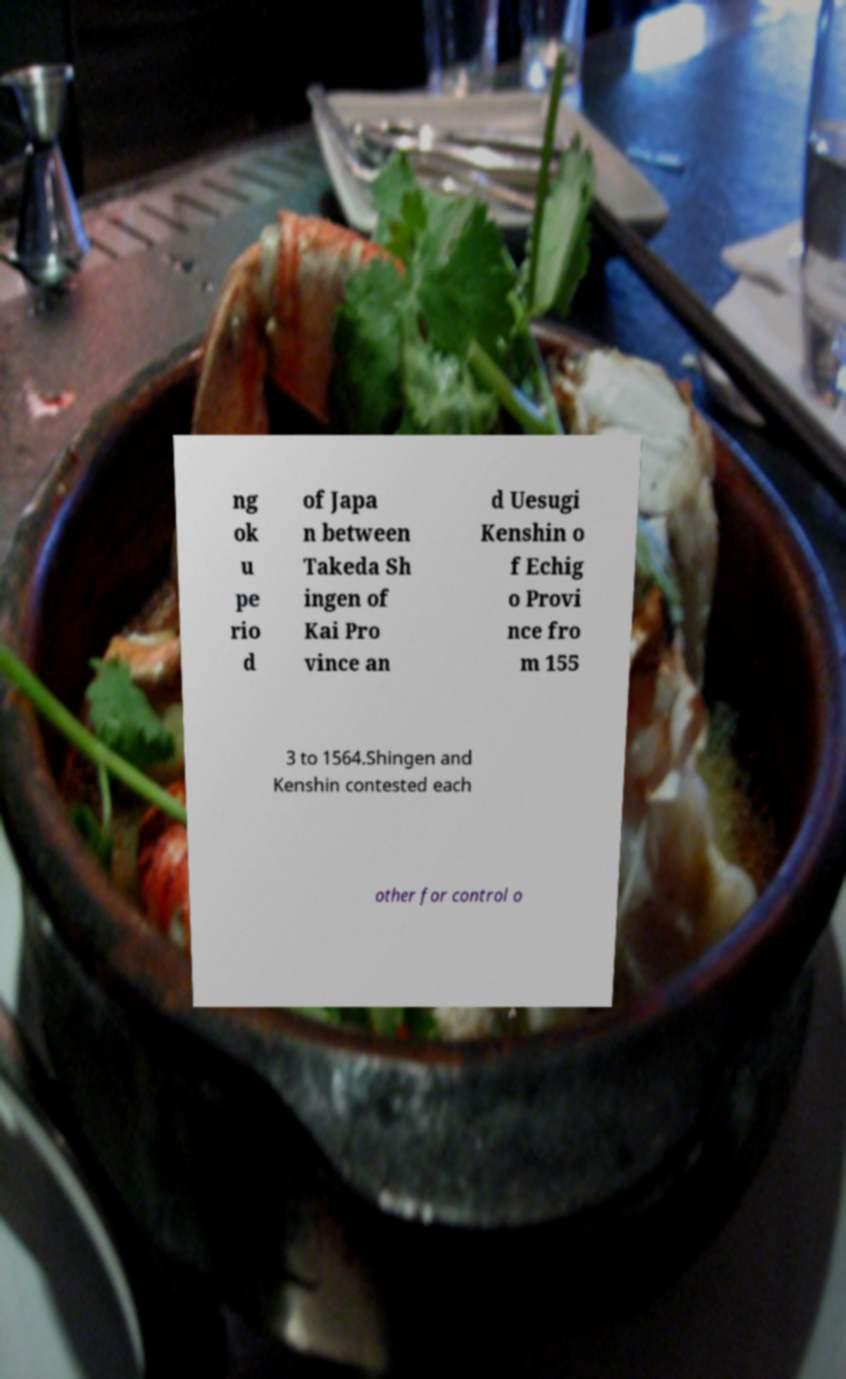Can you read and provide the text displayed in the image?This photo seems to have some interesting text. Can you extract and type it out for me? ng ok u pe rio d of Japa n between Takeda Sh ingen of Kai Pro vince an d Uesugi Kenshin o f Echig o Provi nce fro m 155 3 to 1564.Shingen and Kenshin contested each other for control o 